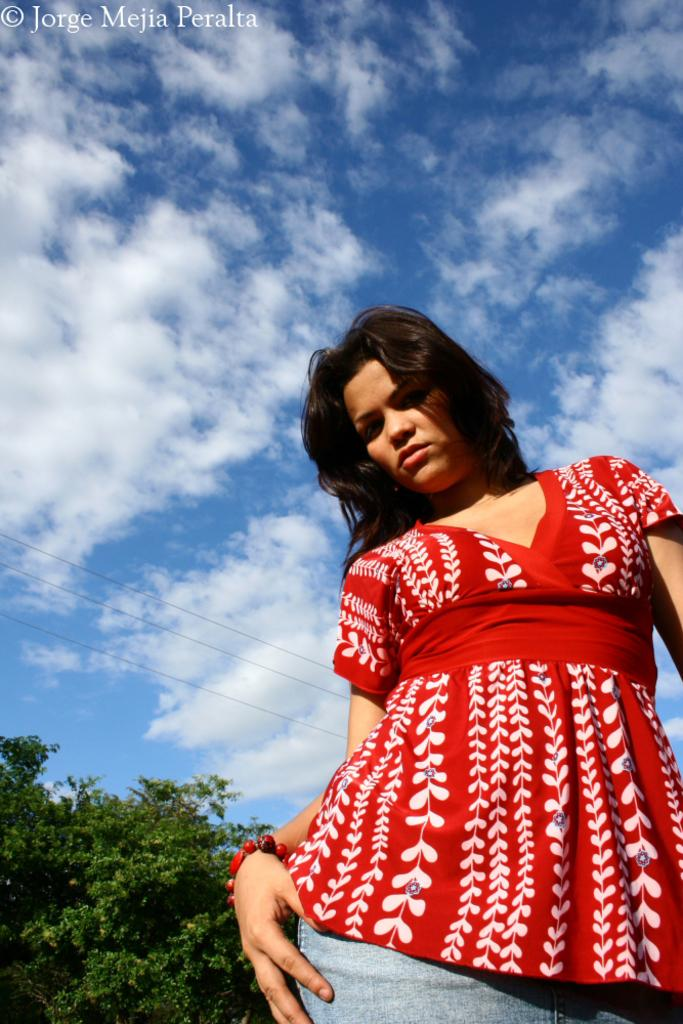Who is present in the image? There is a woman in the image. What is the woman wearing? The woman is wearing a red dress. What type of natural environment is visible in the image? There are trees in the image, and the sky is visible. What can be seen in the sky? There are clouds in the sky. What type of kite is the woman flying in the image? There is no kite present in the image; the woman is simply standing in front of trees and the sky. What game is the woman playing with the trees in the image? There is no game being played in the image; the woman is just standing near the trees. 